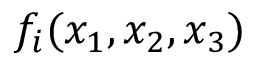<formula> <loc_0><loc_0><loc_500><loc_500>f _ { i } ( x _ { 1 } , x _ { 2 } , x _ { 3 } )</formula> 